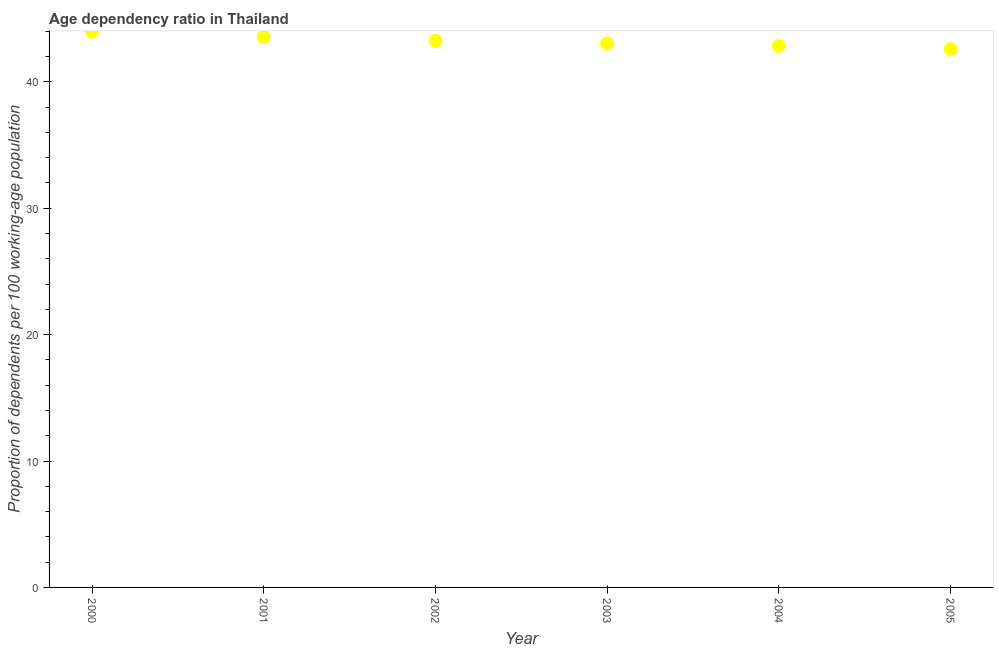What is the age dependency ratio in 2000?
Give a very brief answer. 43.97. Across all years, what is the maximum age dependency ratio?
Your response must be concise. 43.97. Across all years, what is the minimum age dependency ratio?
Your answer should be very brief. 42.59. In which year was the age dependency ratio minimum?
Your answer should be compact. 2005. What is the sum of the age dependency ratio?
Your response must be concise. 259.26. What is the difference between the age dependency ratio in 2000 and 2003?
Make the answer very short. 0.93. What is the average age dependency ratio per year?
Provide a succinct answer. 43.21. What is the median age dependency ratio?
Give a very brief answer. 43.15. Do a majority of the years between 2001 and 2005 (inclusive) have age dependency ratio greater than 28 ?
Keep it short and to the point. Yes. What is the ratio of the age dependency ratio in 2000 to that in 2003?
Keep it short and to the point. 1.02. What is the difference between the highest and the second highest age dependency ratio?
Offer a very short reply. 0.42. What is the difference between the highest and the lowest age dependency ratio?
Offer a terse response. 1.38. In how many years, is the age dependency ratio greater than the average age dependency ratio taken over all years?
Your answer should be compact. 3. How many dotlines are there?
Provide a succinct answer. 1. How many years are there in the graph?
Give a very brief answer. 6. What is the difference between two consecutive major ticks on the Y-axis?
Your response must be concise. 10. Are the values on the major ticks of Y-axis written in scientific E-notation?
Make the answer very short. No. What is the title of the graph?
Your response must be concise. Age dependency ratio in Thailand. What is the label or title of the Y-axis?
Provide a short and direct response. Proportion of dependents per 100 working-age population. What is the Proportion of dependents per 100 working-age population in 2000?
Your answer should be compact. 43.97. What is the Proportion of dependents per 100 working-age population in 2001?
Your answer should be very brief. 43.55. What is the Proportion of dependents per 100 working-age population in 2002?
Ensure brevity in your answer.  43.25. What is the Proportion of dependents per 100 working-age population in 2003?
Offer a very short reply. 43.04. What is the Proportion of dependents per 100 working-age population in 2004?
Keep it short and to the point. 42.85. What is the Proportion of dependents per 100 working-age population in 2005?
Make the answer very short. 42.59. What is the difference between the Proportion of dependents per 100 working-age population in 2000 and 2001?
Make the answer very short. 0.42. What is the difference between the Proportion of dependents per 100 working-age population in 2000 and 2002?
Your answer should be compact. 0.72. What is the difference between the Proportion of dependents per 100 working-age population in 2000 and 2003?
Make the answer very short. 0.93. What is the difference between the Proportion of dependents per 100 working-age population in 2000 and 2004?
Give a very brief answer. 1.13. What is the difference between the Proportion of dependents per 100 working-age population in 2000 and 2005?
Your response must be concise. 1.38. What is the difference between the Proportion of dependents per 100 working-age population in 2001 and 2002?
Give a very brief answer. 0.3. What is the difference between the Proportion of dependents per 100 working-age population in 2001 and 2003?
Keep it short and to the point. 0.51. What is the difference between the Proportion of dependents per 100 working-age population in 2001 and 2004?
Offer a very short reply. 0.71. What is the difference between the Proportion of dependents per 100 working-age population in 2001 and 2005?
Offer a very short reply. 0.96. What is the difference between the Proportion of dependents per 100 working-age population in 2002 and 2003?
Provide a short and direct response. 0.21. What is the difference between the Proportion of dependents per 100 working-age population in 2002 and 2004?
Offer a terse response. 0.41. What is the difference between the Proportion of dependents per 100 working-age population in 2002 and 2005?
Provide a succinct answer. 0.66. What is the difference between the Proportion of dependents per 100 working-age population in 2003 and 2004?
Ensure brevity in your answer.  0.2. What is the difference between the Proportion of dependents per 100 working-age population in 2003 and 2005?
Give a very brief answer. 0.45. What is the difference between the Proportion of dependents per 100 working-age population in 2004 and 2005?
Make the answer very short. 0.26. What is the ratio of the Proportion of dependents per 100 working-age population in 2000 to that in 2001?
Offer a terse response. 1.01. What is the ratio of the Proportion of dependents per 100 working-age population in 2000 to that in 2003?
Provide a short and direct response. 1.02. What is the ratio of the Proportion of dependents per 100 working-age population in 2000 to that in 2004?
Your answer should be very brief. 1.03. What is the ratio of the Proportion of dependents per 100 working-age population in 2000 to that in 2005?
Your response must be concise. 1.03. What is the ratio of the Proportion of dependents per 100 working-age population in 2001 to that in 2003?
Provide a short and direct response. 1.01. What is the ratio of the Proportion of dependents per 100 working-age population in 2001 to that in 2004?
Ensure brevity in your answer.  1.02. What is the ratio of the Proportion of dependents per 100 working-age population in 2001 to that in 2005?
Your answer should be compact. 1.02. What is the ratio of the Proportion of dependents per 100 working-age population in 2003 to that in 2004?
Ensure brevity in your answer.  1. What is the ratio of the Proportion of dependents per 100 working-age population in 2004 to that in 2005?
Your answer should be very brief. 1.01. 